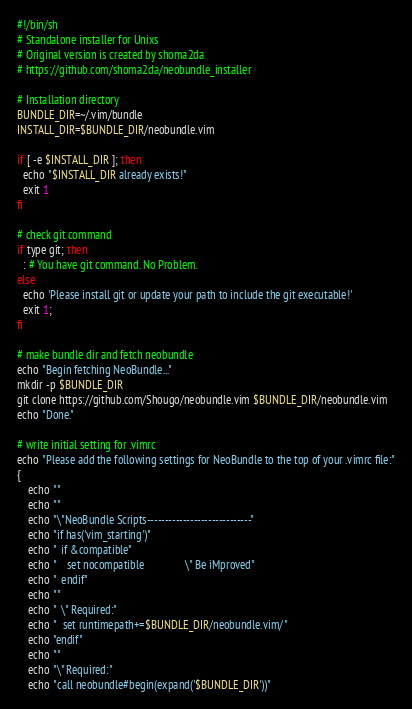<code> <loc_0><loc_0><loc_500><loc_500><_Bash_>#!/bin/sh
# Standalone installer for Unixs
# Original version is created by shoma2da
# https://github.com/shoma2da/neobundle_installer

# Installation directory
BUNDLE_DIR=~/.vim/bundle
INSTALL_DIR=$BUNDLE_DIR/neobundle.vim

if [ -e $INSTALL_DIR ]; then
  echo "$INSTALL_DIR already exists!"
  exit 1
fi

# check git command
if type git; then
  : # You have git command. No Problem.
else
  echo 'Please install git or update your path to include the git executable!'
  exit 1;
fi

# make bundle dir and fetch neobundle
echo "Begin fetching NeoBundle..."
mkdir -p $BUNDLE_DIR
git clone https://github.com/Shougo/neobundle.vim $BUNDLE_DIR/neobundle.vim
echo "Done."

# write initial setting for .vimrc
echo "Please add the following settings for NeoBundle to the top of your .vimrc file:"
{
    echo ""
    echo ""
    echo "\"NeoBundle Scripts-----------------------------"
    echo "if has('vim_starting')"
    echo "  if &compatible"
    echo "    set nocompatible               \" Be iMproved"
    echo "  endif"
    echo ""
    echo "  \" Required:"
    echo "  set runtimepath+=$BUNDLE_DIR/neobundle.vim/"
    echo "endif"
    echo ""
    echo "\" Required:"
    echo "call neobundle#begin(expand('$BUNDLE_DIR'))"</code> 